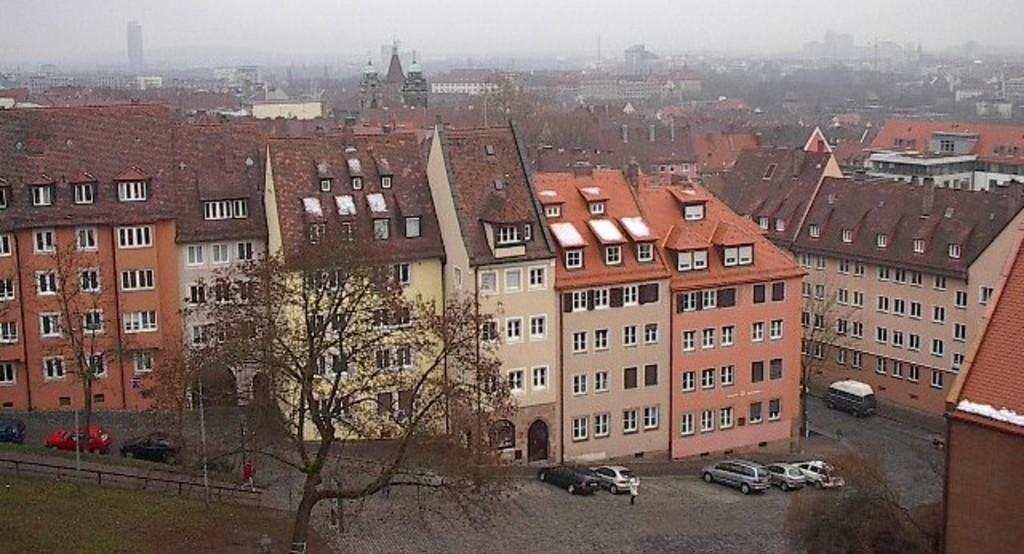What type of structures can be seen in the image? There are buildings in the image. What is parked in front of the buildings? Cars are parked in front of the buildings. What type of vegetation is present in the image? Trees are present in the image. What type of barrier can be seen in the image? There is an iron railing in the image. Can you describe the person's location in the image? A person is near a car in the image. What is visible in the background of the image? The sky is visible in the background of the image. What type of card is being played by the person near the car in the image? There is no card or card game present in the image. How quiet is the environment in the image? The image does not provide any information about the noise level or quietness of the environment. 